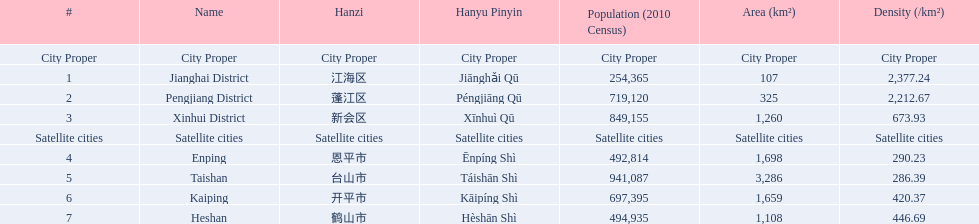What are all of the city proper district names? Jianghai District, Pengjiang District, Xinhui District. Of those districts, what are is the value for their area (km2)? 107, 325, 1,260. Of those area values, which district does the smallest value belong to? Jianghai District. 